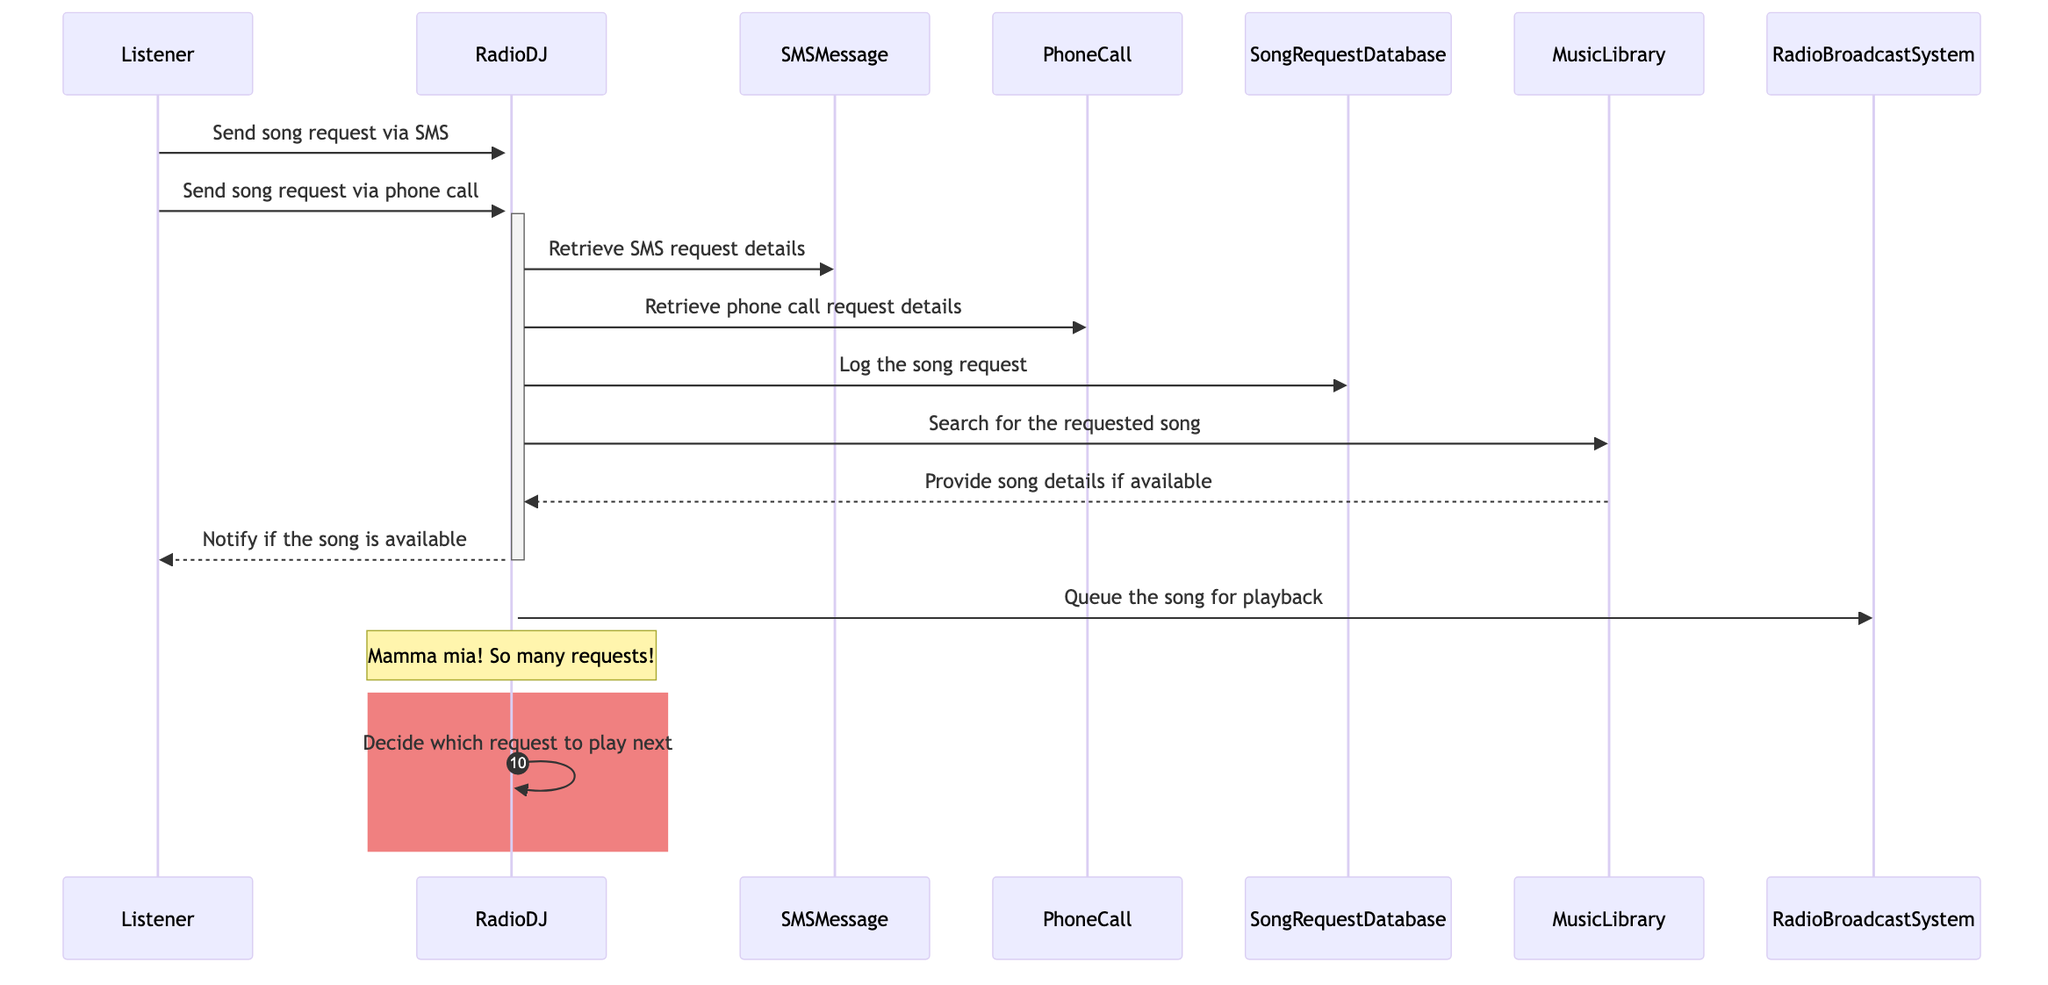What's the total number of actors in the diagram? The diagram includes three actors: Listener, RadioDJ, and the two objects (SMSMessage, PhoneCall) are not classified as actors. Therefore, the total number of distinct actors is three.
Answer: 2 How many messages are sent from Listener to RadioDJ? The Listener sends two messages: one for the song request via SMS and one for the song request via phone call. Thus, the total messages sent from Listener to RadioDJ is two.
Answer: 2 Which entity retrieves the phone call request details? The diagram shows that the RadioDJ interacts with the PhoneCall entity to retrieve phone call request details. Therefore, the entity responsible is RadioDJ.
Answer: RadioDJ What action does RadioDJ take after logging the song request? After logging the song request, RadioDJ's next action is to search for the requested song in the MusicLibrary. This indicates that the subsequent step involves checking the availability of the song.
Answer: Search for the requested song List the database entity involved in managing song requests. The SongRequestDatabase is specifically designed to log song requests and manage them during the show. Thus, it is the main entity involved in this operation.
Answer: SongRequestDatabase What is the last action taken by RadioDJ in the diagram? The last action taken by RadioDJ is to queue the song for playback in the RadioBroadcastSystem, indicating that the song request process has concluded with actions resulting in the song being played.
Answer: Queue the song for playback How does RadioDJ notify the Listener? RadioDJ informs the Listener by sending a notification if the requested song is available, indicating whether it can be played on-air. Thus, notification is the method of communication here.
Answer: Notify if the song is available What does the note over RadioDJ imply? The note over RadioDJ indicates that there are multiple requests being received, highlighting the possible overwhelming situation RadioDJ is facing during the live show, emphasizing the busy nature of managing requests.
Answer: So many requests! 